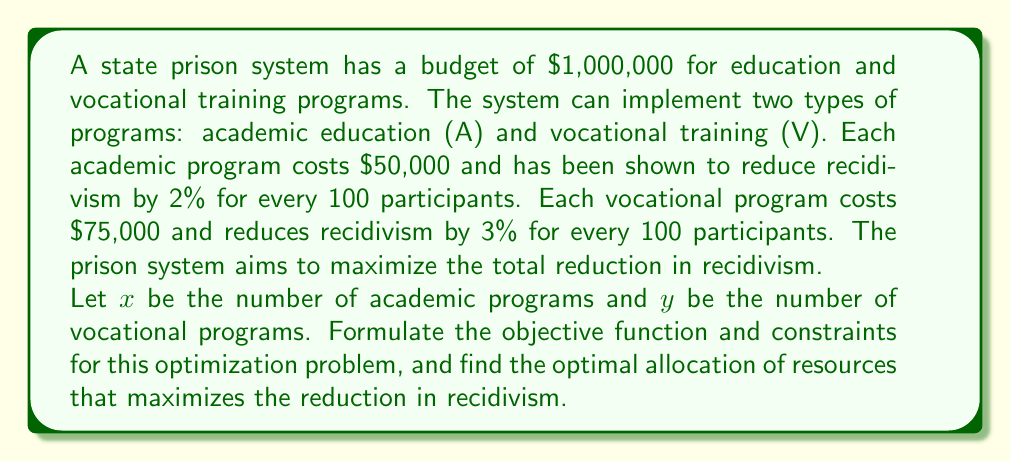Could you help me with this problem? To solve this problem, we need to follow these steps:

1. Formulate the objective function:
   The goal is to maximize the reduction in recidivism. For every academic program, we reduce recidivism by 2% per 100 participants, and for every vocational program, we reduce it by 3% per 100 participants.

   Objective function: Maximize $f(x,y) = 0.02x + 0.03y$

2. Identify the constraints:
   a) Budget constraint: The total cost of programs cannot exceed $1,000,000
      $50,000x + 75,000y \leq 1,000,000$
   
   b) Non-negativity constraints: The number of programs cannot be negative
      $x \geq 0$ and $y \geq 0$

3. Simplify the constraints:
   Budget constraint: $50x + 75y \leq 1000$ (dividing everything by 1000)

4. Use the graphical method to solve this linear programming problem:
   Plot the constraints:
   $50x + 75y = 1000$ (budget line)
   $x = 0$ and $y = 0$ (axes)

5. Find the corner points of the feasible region:
   (0, 0), (20, 0), (0, 13.33), and the intersection of $x = 0$ and $y = 0$

6. Evaluate the objective function at these corner points:
   $f(0, 0) = 0$
   $f(20, 0) = 0.4$
   $f(0, 13.33) = 0.4$

7. The optimal solution is the point that gives the maximum value of the objective function. In this case, we have two optimal solutions:
   (20, 0) and (0, 13.33)

8. Interpret the results:
   Option 1: Implement 20 academic programs
   Option 2: Implement 13 vocational programs (rounding down to stay within budget)

Both options result in a 40% reduction in recidivism.
Answer: The optimal allocation of resources to maximize the reduction in recidivism can be achieved in two ways:

1. Implement 20 academic programs ($x = 20, y = 0$)
2. Implement 13 vocational programs ($x = 0, y = 13$)

Both options result in a 40% reduction in recidivism. 